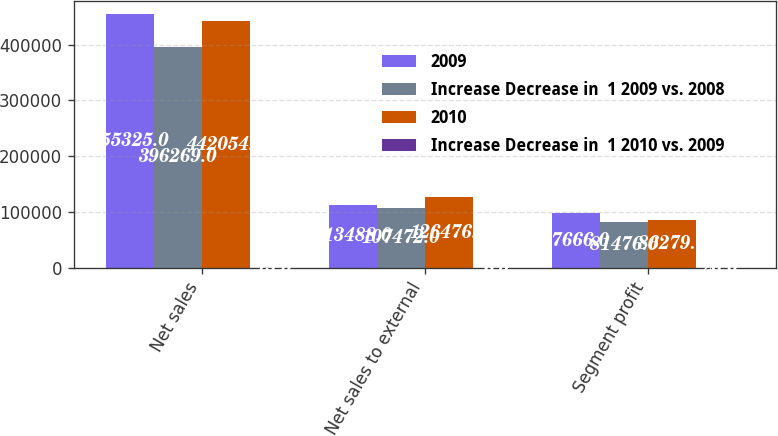Convert chart to OTSL. <chart><loc_0><loc_0><loc_500><loc_500><stacked_bar_chart><ecel><fcel>Net sales<fcel>Net sales to external<fcel>Segment profit<nl><fcel>2009<fcel>455325<fcel>113488<fcel>97666<nl><fcel>Increase Decrease in  1 2009 vs. 2008<fcel>396269<fcel>107472<fcel>81476<nl><fcel>2010<fcel>442054<fcel>126476<fcel>86279<nl><fcel>Increase Decrease in  1 2010 vs. 2009<fcel>15<fcel>6<fcel>20<nl></chart> 